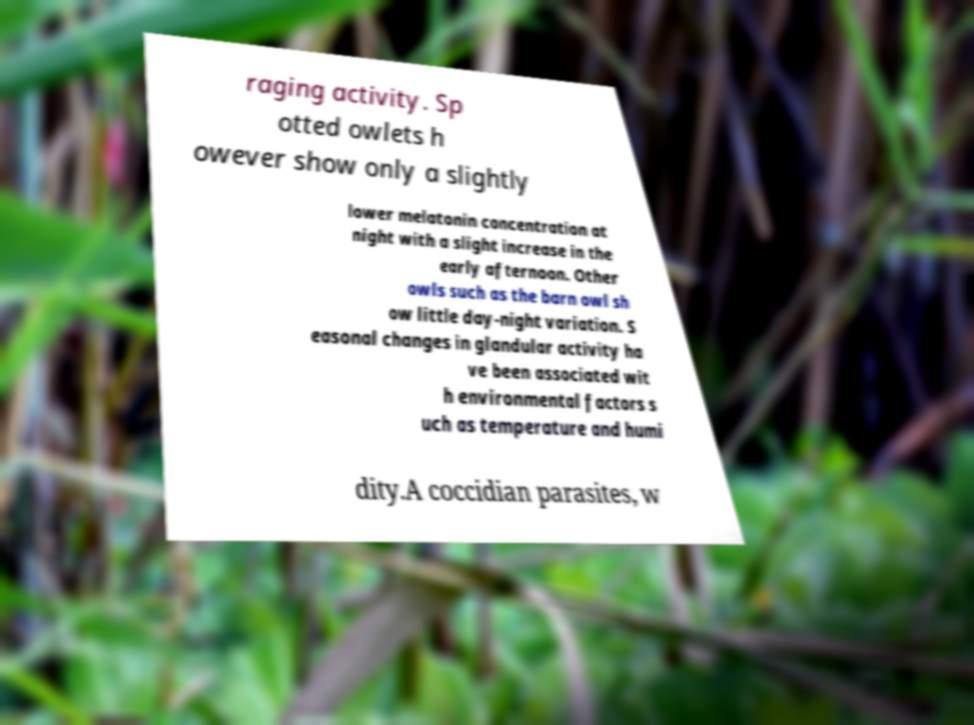Can you read and provide the text displayed in the image?This photo seems to have some interesting text. Can you extract and type it out for me? raging activity. Sp otted owlets h owever show only a slightly lower melatonin concentration at night with a slight increase in the early afternoon. Other owls such as the barn owl sh ow little day-night variation. S easonal changes in glandular activity ha ve been associated wit h environmental factors s uch as temperature and humi dity.A coccidian parasites, w 